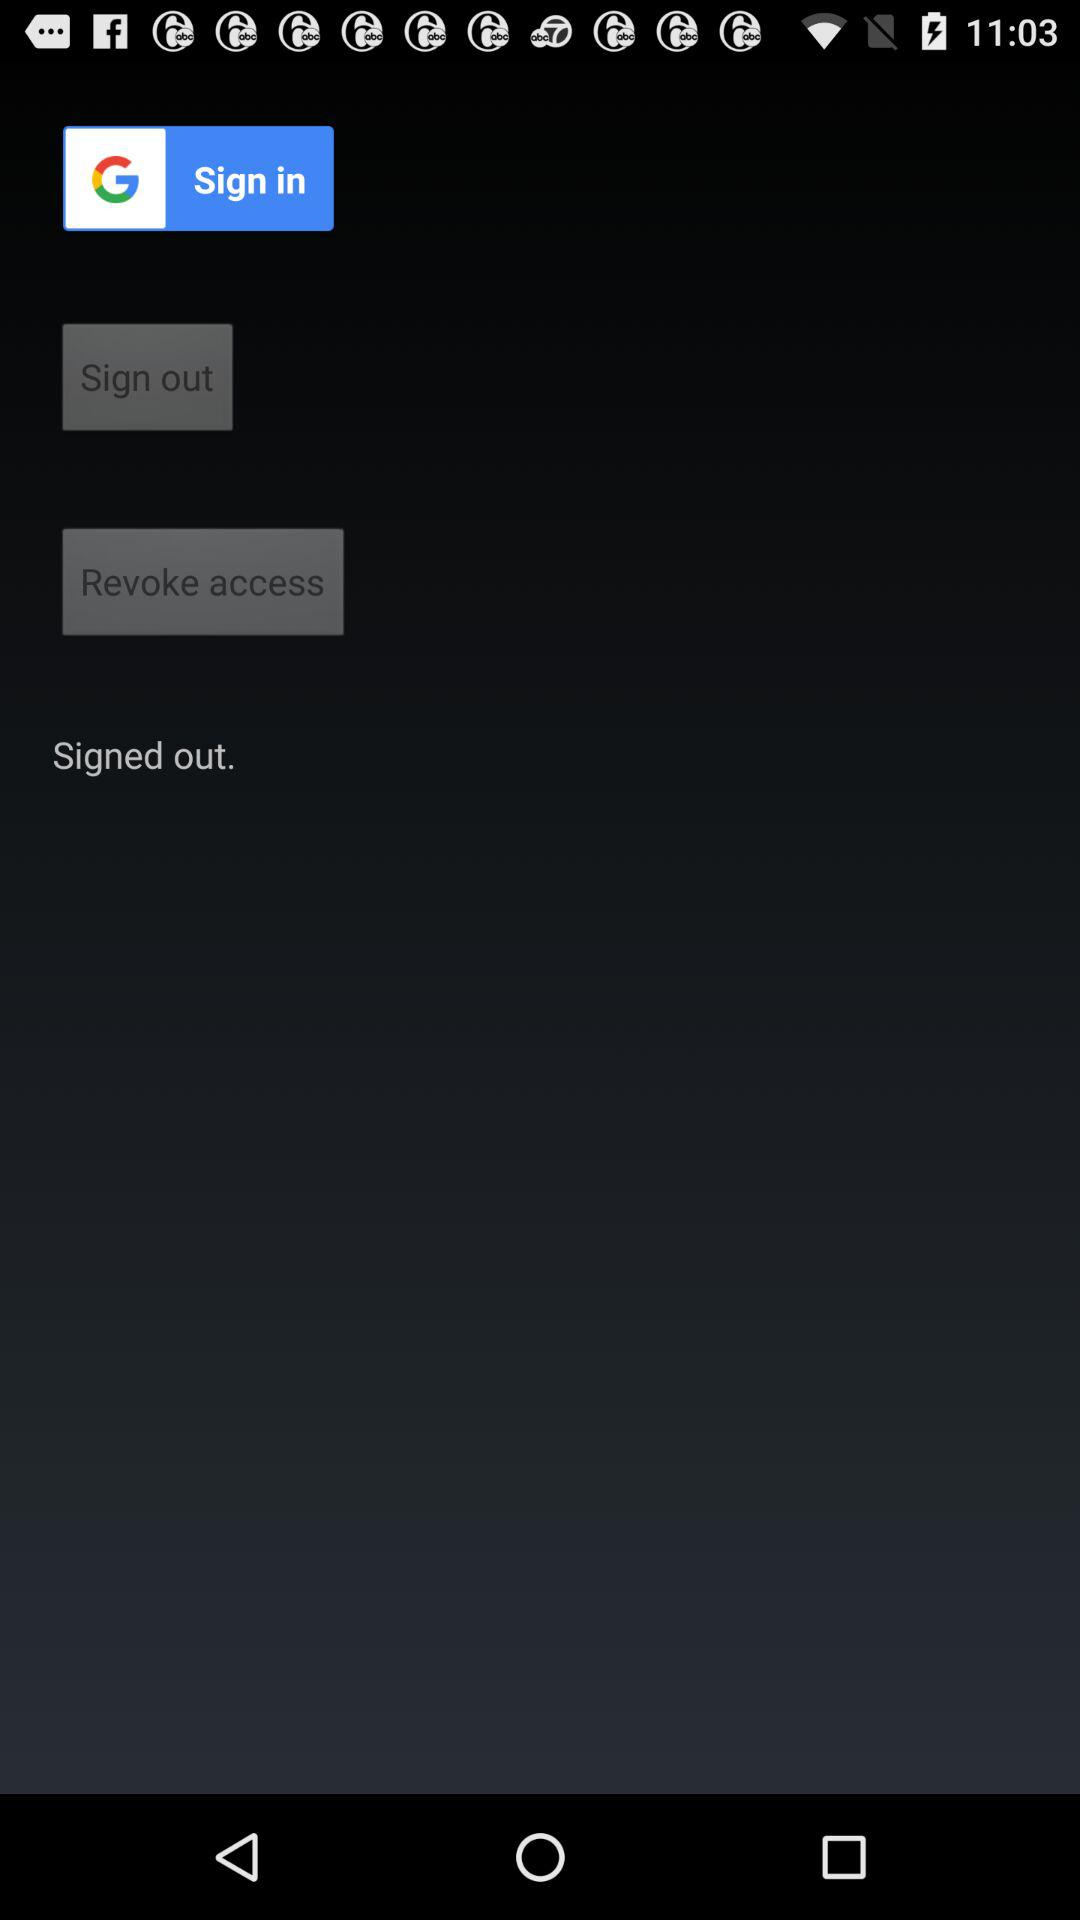Through what app can I sign in? You can sign in through "Google". 